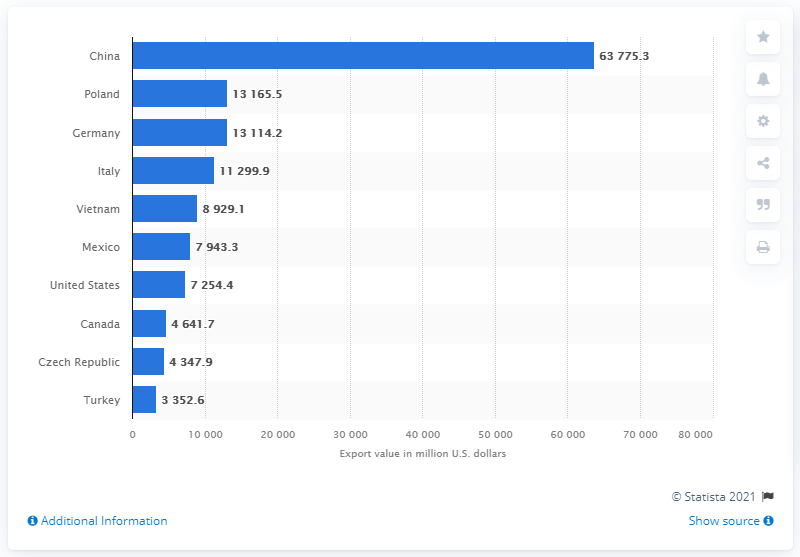Highlight a few significant elements in this photo. In 2019, China was the leading exporter of furniture to the rest of the world. In 2019, Poland exported 13,165.5 units of furniture to the United States. In 2019, China's export value in US dollars was 63,775.3 million dollars. 